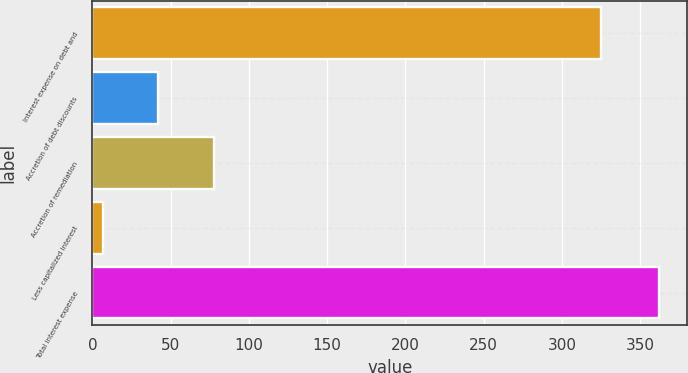Convert chart to OTSL. <chart><loc_0><loc_0><loc_500><loc_500><bar_chart><fcel>Interest expense on debt and<fcel>Accretion of debt discounts<fcel>Accretion of remediation<fcel>Less capitalized interest<fcel>Total interest expense<nl><fcel>324.8<fcel>42.04<fcel>77.58<fcel>6.5<fcel>361.9<nl></chart> 